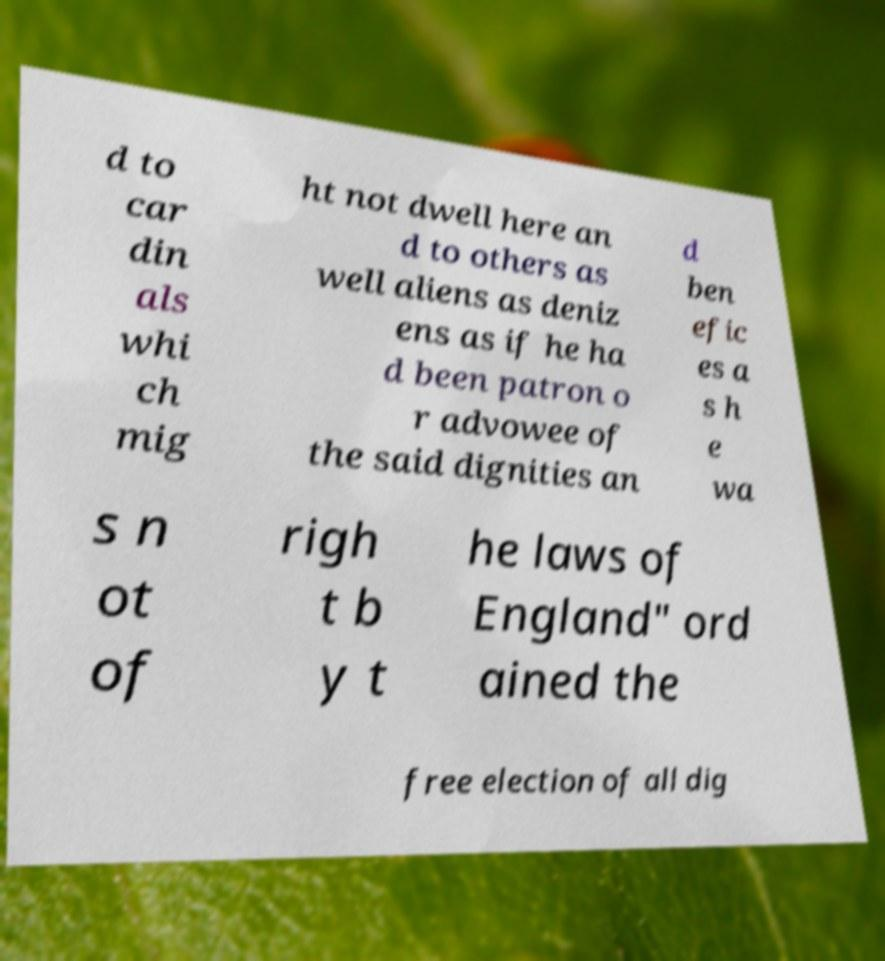Can you accurately transcribe the text from the provided image for me? d to car din als whi ch mig ht not dwell here an d to others as well aliens as deniz ens as if he ha d been patron o r advowee of the said dignities an d ben efic es a s h e wa s n ot of righ t b y t he laws of England" ord ained the free election of all dig 